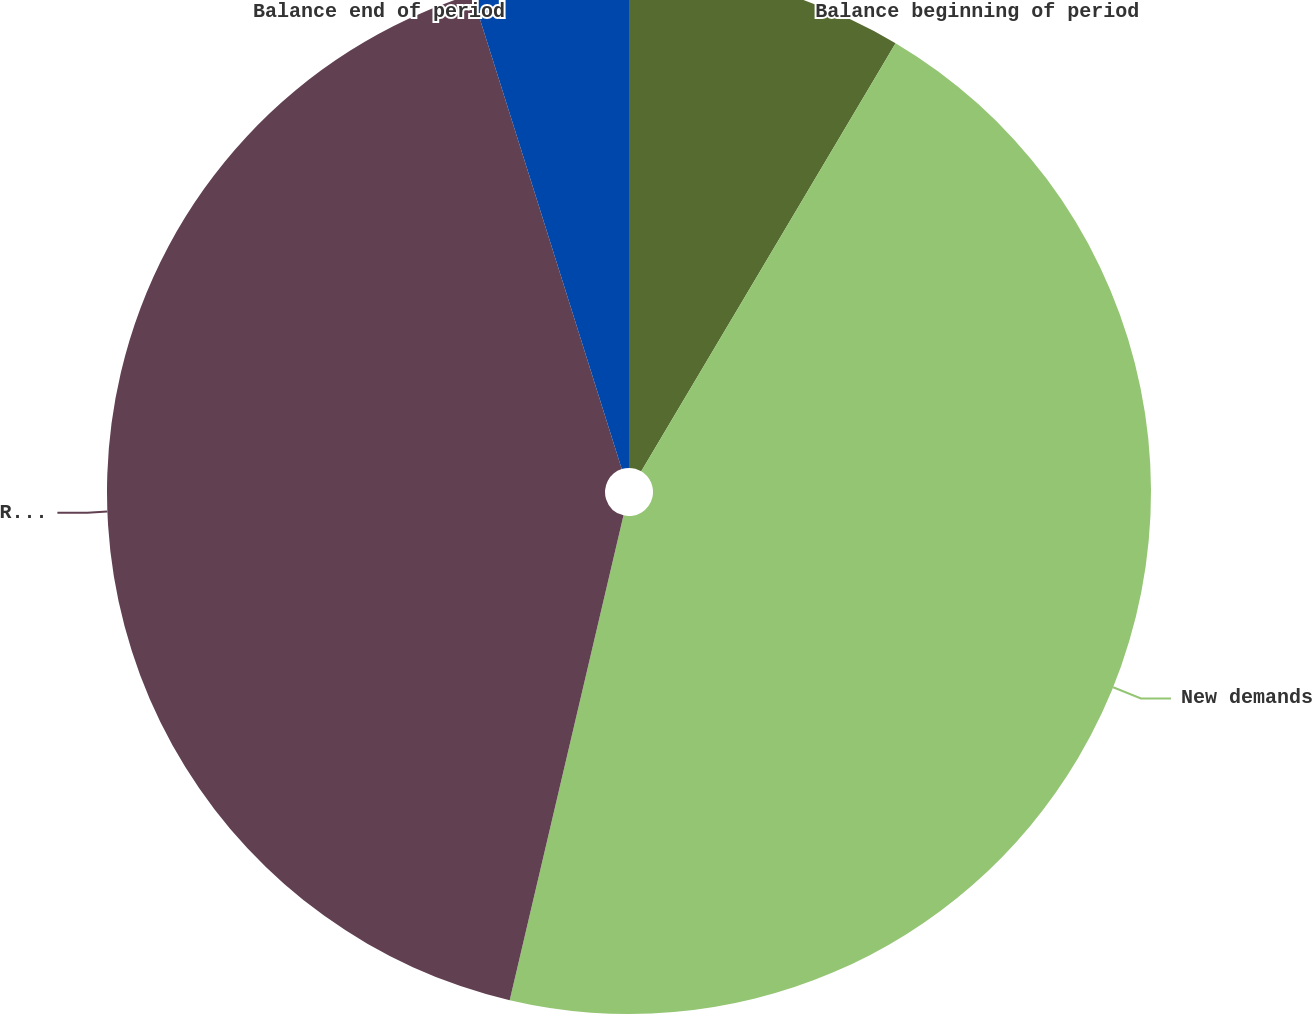Convert chart. <chart><loc_0><loc_0><loc_500><loc_500><pie_chart><fcel>Balance beginning of period<fcel>New demands<fcel>Resolved demands<fcel>Balance end of period<nl><fcel>8.53%<fcel>45.14%<fcel>41.47%<fcel>4.86%<nl></chart> 